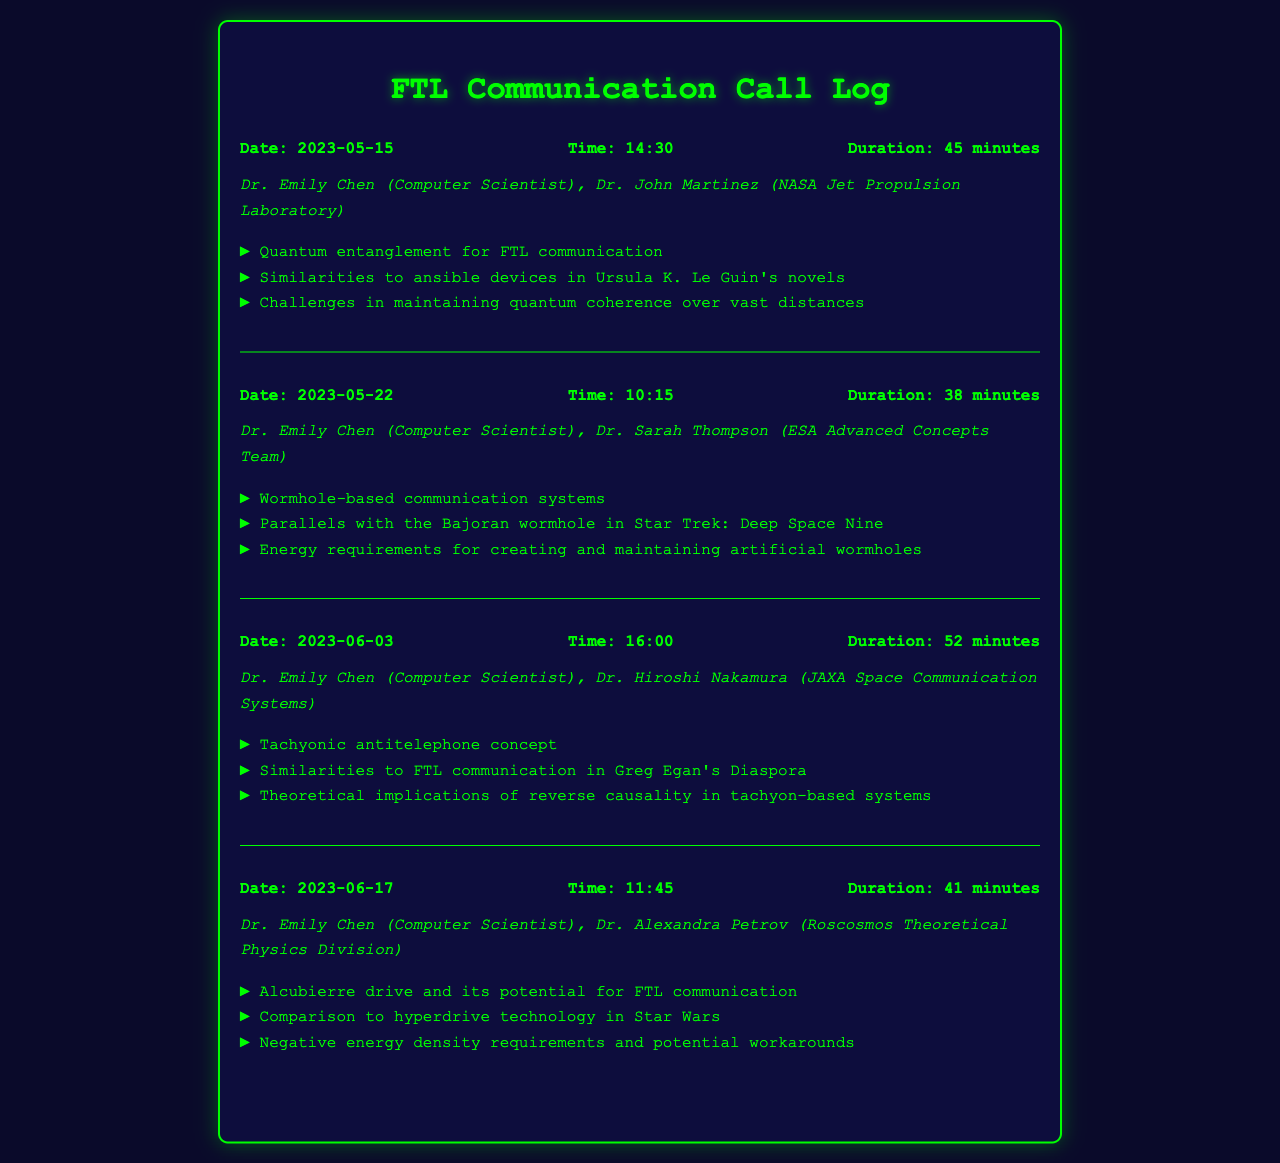What is the date of the first call? The first call took place on May 15, 2023.
Answer: May 15, 2023 Who was the participant in the first call from NASA? Dr. John Martinez participated on behalf of NASA Jet Propulsion Laboratory in the first call.
Answer: Dr. John Martinez What is the duration of the second call? The second call lasted for 38 minutes as stated in the call log.
Answer: 38 minutes Which science fiction novel series is mentioned in the context of wormhole-based communication systems? The Bajoran wormhole from Star Trek: Deep Space Nine is referenced.
Answer: Star Trek: Deep Space Nine What is one of the challenges mentioned in the first call regarding FTL communication? Maintaining quantum coherence over vast distances is cited as a challenge during the discussion.
Answer: Maintaining quantum coherence What is the total number of calls recorded in the document? There are four call logs listed in the document.
Answer: Four Which theoretical concept is associated with reverse causality? The tachyonic antitelephone concept is discussed in relation to reverse causality.
Answer: Tachyonic antitelephone What was the focus of the last call on June 17? The focus was on the Alcubierre drive and its potential for FTL communication.
Answer: Alcubierre drive Which agency's official was Dr. Emily Chen in communication with on June 3? Dr. Hiroshi Nakamura from JAXA Space Communication Systems participated in the call on June 3.
Answer: JAXA Space Communication Systems 